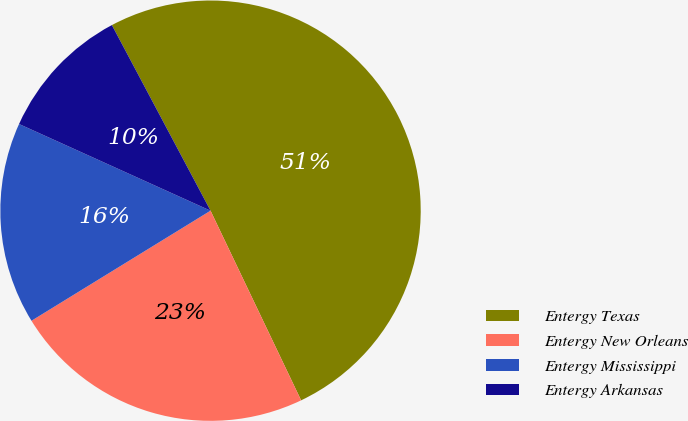Convert chart to OTSL. <chart><loc_0><loc_0><loc_500><loc_500><pie_chart><fcel>Entergy Texas<fcel>Entergy New Orleans<fcel>Entergy Mississippi<fcel>Entergy Arkansas<nl><fcel>50.69%<fcel>23.32%<fcel>15.54%<fcel>10.46%<nl></chart> 